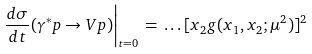Convert formula to latex. <formula><loc_0><loc_0><loc_500><loc_500>\left . \frac { d \sigma } { d t } ( \gamma ^ { * } p \rightarrow V p ) \right | _ { t = 0 } \, = \, \dots [ x _ { 2 } g ( x _ { 1 } , x _ { 2 } ; \mu ^ { 2 } ) ] ^ { 2 }</formula> 